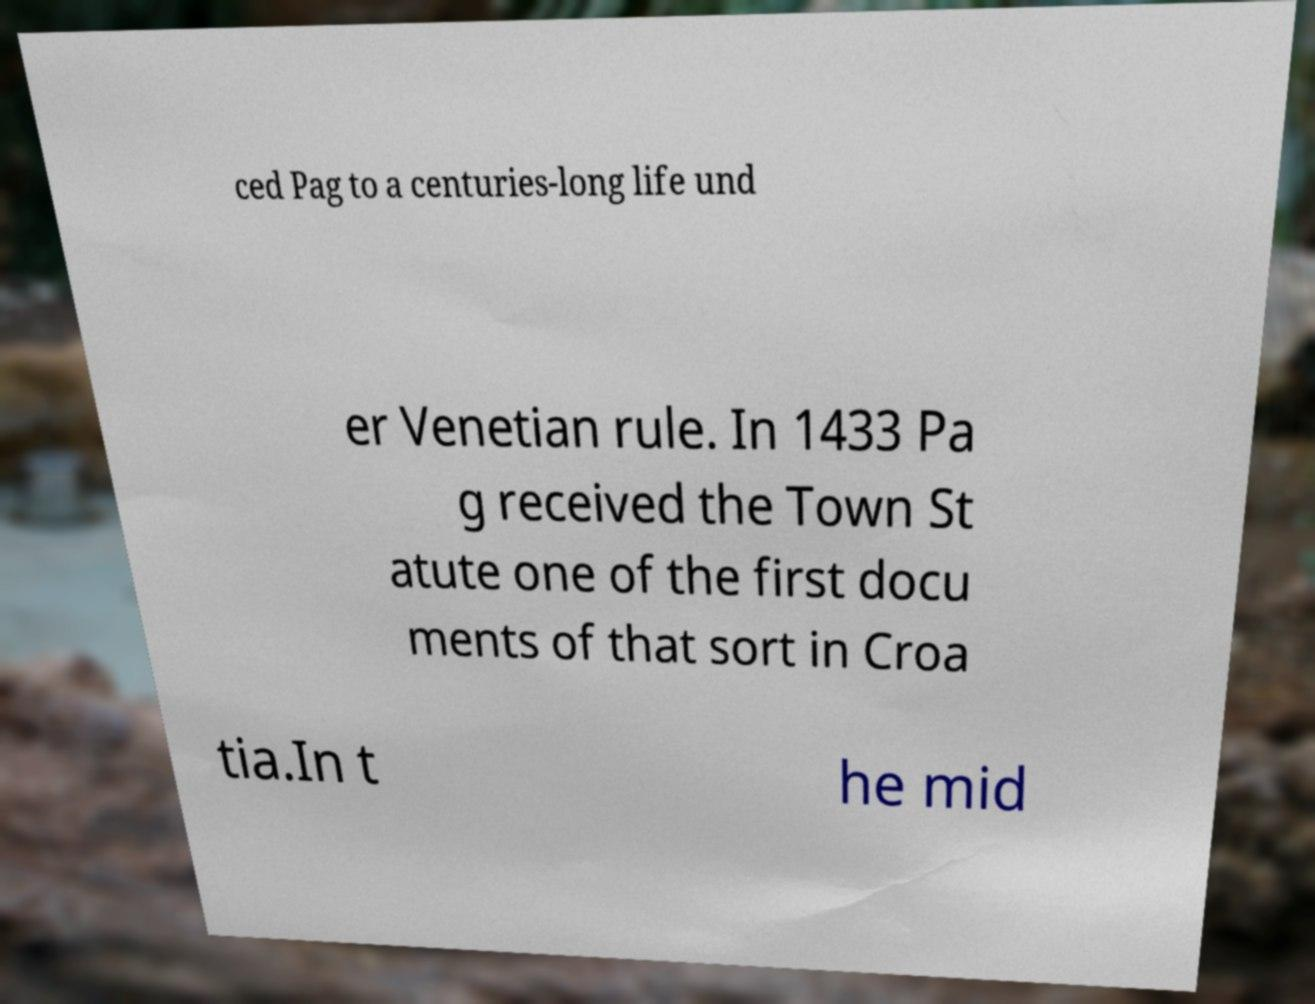There's text embedded in this image that I need extracted. Can you transcribe it verbatim? ced Pag to a centuries-long life und er Venetian rule. In 1433 Pa g received the Town St atute one of the first docu ments of that sort in Croa tia.In t he mid 